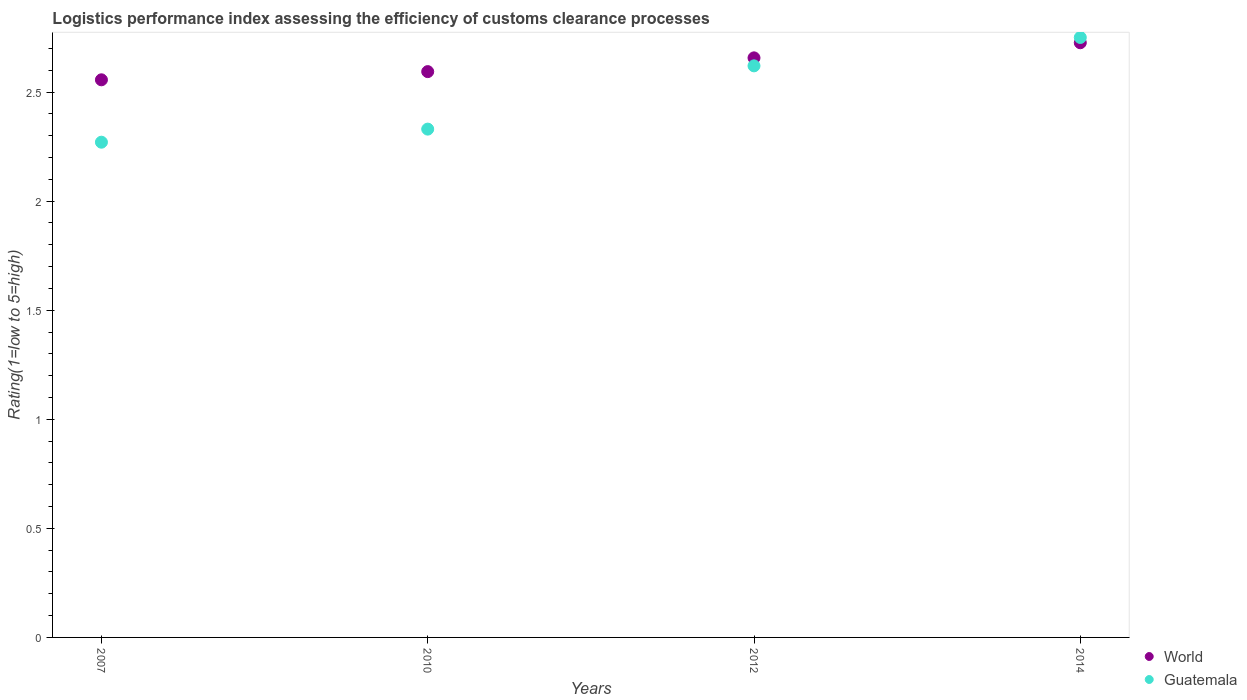Is the number of dotlines equal to the number of legend labels?
Your answer should be compact. Yes. What is the Logistic performance index in World in 2010?
Offer a terse response. 2.59. Across all years, what is the maximum Logistic performance index in World?
Offer a terse response. 2.73. Across all years, what is the minimum Logistic performance index in Guatemala?
Ensure brevity in your answer.  2.27. In which year was the Logistic performance index in Guatemala maximum?
Ensure brevity in your answer.  2014. What is the total Logistic performance index in Guatemala in the graph?
Offer a very short reply. 9.97. What is the difference between the Logistic performance index in Guatemala in 2007 and that in 2010?
Offer a very short reply. -0.06. What is the difference between the Logistic performance index in Guatemala in 2014 and the Logistic performance index in World in 2007?
Make the answer very short. 0.19. What is the average Logistic performance index in Guatemala per year?
Offer a very short reply. 2.49. In the year 2007, what is the difference between the Logistic performance index in Guatemala and Logistic performance index in World?
Provide a succinct answer. -0.29. In how many years, is the Logistic performance index in World greater than 0.1?
Provide a succinct answer. 4. What is the ratio of the Logistic performance index in World in 2007 to that in 2010?
Provide a short and direct response. 0.99. Is the Logistic performance index in Guatemala in 2010 less than that in 2012?
Ensure brevity in your answer.  Yes. Is the difference between the Logistic performance index in Guatemala in 2010 and 2014 greater than the difference between the Logistic performance index in World in 2010 and 2014?
Your answer should be very brief. No. What is the difference between the highest and the second highest Logistic performance index in World?
Provide a short and direct response. 0.07. What is the difference between the highest and the lowest Logistic performance index in World?
Provide a short and direct response. 0.17. Is the sum of the Logistic performance index in Guatemala in 2012 and 2014 greater than the maximum Logistic performance index in World across all years?
Give a very brief answer. Yes. Does the Logistic performance index in Guatemala monotonically increase over the years?
Keep it short and to the point. Yes. Is the Logistic performance index in Guatemala strictly greater than the Logistic performance index in World over the years?
Offer a terse response. No. How many years are there in the graph?
Offer a very short reply. 4. What is the difference between two consecutive major ticks on the Y-axis?
Your answer should be very brief. 0.5. Does the graph contain any zero values?
Give a very brief answer. No. How many legend labels are there?
Provide a short and direct response. 2. How are the legend labels stacked?
Keep it short and to the point. Vertical. What is the title of the graph?
Provide a succinct answer. Logistics performance index assessing the efficiency of customs clearance processes. Does "Sub-Saharan Africa (developing only)" appear as one of the legend labels in the graph?
Offer a terse response. No. What is the label or title of the X-axis?
Provide a succinct answer. Years. What is the label or title of the Y-axis?
Make the answer very short. Rating(1=low to 5=high). What is the Rating(1=low to 5=high) in World in 2007?
Give a very brief answer. 2.56. What is the Rating(1=low to 5=high) in Guatemala in 2007?
Your answer should be very brief. 2.27. What is the Rating(1=low to 5=high) of World in 2010?
Ensure brevity in your answer.  2.59. What is the Rating(1=low to 5=high) of Guatemala in 2010?
Your answer should be very brief. 2.33. What is the Rating(1=low to 5=high) of World in 2012?
Your answer should be compact. 2.66. What is the Rating(1=low to 5=high) in Guatemala in 2012?
Keep it short and to the point. 2.62. What is the Rating(1=low to 5=high) of World in 2014?
Your answer should be compact. 2.73. What is the Rating(1=low to 5=high) in Guatemala in 2014?
Keep it short and to the point. 2.75. Across all years, what is the maximum Rating(1=low to 5=high) in World?
Ensure brevity in your answer.  2.73. Across all years, what is the maximum Rating(1=low to 5=high) in Guatemala?
Keep it short and to the point. 2.75. Across all years, what is the minimum Rating(1=low to 5=high) in World?
Your response must be concise. 2.56. Across all years, what is the minimum Rating(1=low to 5=high) of Guatemala?
Give a very brief answer. 2.27. What is the total Rating(1=low to 5=high) in World in the graph?
Provide a short and direct response. 10.53. What is the total Rating(1=low to 5=high) in Guatemala in the graph?
Provide a short and direct response. 9.97. What is the difference between the Rating(1=low to 5=high) in World in 2007 and that in 2010?
Keep it short and to the point. -0.04. What is the difference between the Rating(1=low to 5=high) in Guatemala in 2007 and that in 2010?
Ensure brevity in your answer.  -0.06. What is the difference between the Rating(1=low to 5=high) in World in 2007 and that in 2012?
Ensure brevity in your answer.  -0.1. What is the difference between the Rating(1=low to 5=high) in Guatemala in 2007 and that in 2012?
Make the answer very short. -0.35. What is the difference between the Rating(1=low to 5=high) of World in 2007 and that in 2014?
Give a very brief answer. -0.17. What is the difference between the Rating(1=low to 5=high) of Guatemala in 2007 and that in 2014?
Give a very brief answer. -0.48. What is the difference between the Rating(1=low to 5=high) of World in 2010 and that in 2012?
Provide a short and direct response. -0.06. What is the difference between the Rating(1=low to 5=high) in Guatemala in 2010 and that in 2012?
Make the answer very short. -0.29. What is the difference between the Rating(1=low to 5=high) of World in 2010 and that in 2014?
Ensure brevity in your answer.  -0.13. What is the difference between the Rating(1=low to 5=high) in Guatemala in 2010 and that in 2014?
Offer a terse response. -0.42. What is the difference between the Rating(1=low to 5=high) of World in 2012 and that in 2014?
Offer a very short reply. -0.07. What is the difference between the Rating(1=low to 5=high) of Guatemala in 2012 and that in 2014?
Offer a very short reply. -0.13. What is the difference between the Rating(1=low to 5=high) of World in 2007 and the Rating(1=low to 5=high) of Guatemala in 2010?
Make the answer very short. 0.23. What is the difference between the Rating(1=low to 5=high) of World in 2007 and the Rating(1=low to 5=high) of Guatemala in 2012?
Provide a short and direct response. -0.06. What is the difference between the Rating(1=low to 5=high) of World in 2007 and the Rating(1=low to 5=high) of Guatemala in 2014?
Give a very brief answer. -0.19. What is the difference between the Rating(1=low to 5=high) of World in 2010 and the Rating(1=low to 5=high) of Guatemala in 2012?
Provide a succinct answer. -0.03. What is the difference between the Rating(1=low to 5=high) in World in 2010 and the Rating(1=low to 5=high) in Guatemala in 2014?
Give a very brief answer. -0.16. What is the difference between the Rating(1=low to 5=high) in World in 2012 and the Rating(1=low to 5=high) in Guatemala in 2014?
Keep it short and to the point. -0.09. What is the average Rating(1=low to 5=high) of World per year?
Your response must be concise. 2.63. What is the average Rating(1=low to 5=high) of Guatemala per year?
Give a very brief answer. 2.49. In the year 2007, what is the difference between the Rating(1=low to 5=high) of World and Rating(1=low to 5=high) of Guatemala?
Ensure brevity in your answer.  0.29. In the year 2010, what is the difference between the Rating(1=low to 5=high) in World and Rating(1=low to 5=high) in Guatemala?
Give a very brief answer. 0.26. In the year 2012, what is the difference between the Rating(1=low to 5=high) of World and Rating(1=low to 5=high) of Guatemala?
Your answer should be compact. 0.04. In the year 2014, what is the difference between the Rating(1=low to 5=high) of World and Rating(1=low to 5=high) of Guatemala?
Give a very brief answer. -0.02. What is the ratio of the Rating(1=low to 5=high) in World in 2007 to that in 2010?
Make the answer very short. 0.99. What is the ratio of the Rating(1=low to 5=high) in Guatemala in 2007 to that in 2010?
Provide a succinct answer. 0.97. What is the ratio of the Rating(1=low to 5=high) of World in 2007 to that in 2012?
Give a very brief answer. 0.96. What is the ratio of the Rating(1=low to 5=high) of Guatemala in 2007 to that in 2012?
Make the answer very short. 0.87. What is the ratio of the Rating(1=low to 5=high) of World in 2007 to that in 2014?
Keep it short and to the point. 0.94. What is the ratio of the Rating(1=low to 5=high) of Guatemala in 2007 to that in 2014?
Ensure brevity in your answer.  0.83. What is the ratio of the Rating(1=low to 5=high) in World in 2010 to that in 2012?
Keep it short and to the point. 0.98. What is the ratio of the Rating(1=low to 5=high) of Guatemala in 2010 to that in 2012?
Make the answer very short. 0.89. What is the ratio of the Rating(1=low to 5=high) of World in 2010 to that in 2014?
Your answer should be compact. 0.95. What is the ratio of the Rating(1=low to 5=high) in Guatemala in 2010 to that in 2014?
Offer a terse response. 0.85. What is the ratio of the Rating(1=low to 5=high) of World in 2012 to that in 2014?
Your response must be concise. 0.97. What is the ratio of the Rating(1=low to 5=high) of Guatemala in 2012 to that in 2014?
Ensure brevity in your answer.  0.95. What is the difference between the highest and the second highest Rating(1=low to 5=high) in World?
Give a very brief answer. 0.07. What is the difference between the highest and the second highest Rating(1=low to 5=high) in Guatemala?
Offer a very short reply. 0.13. What is the difference between the highest and the lowest Rating(1=low to 5=high) of World?
Give a very brief answer. 0.17. What is the difference between the highest and the lowest Rating(1=low to 5=high) in Guatemala?
Your answer should be very brief. 0.48. 